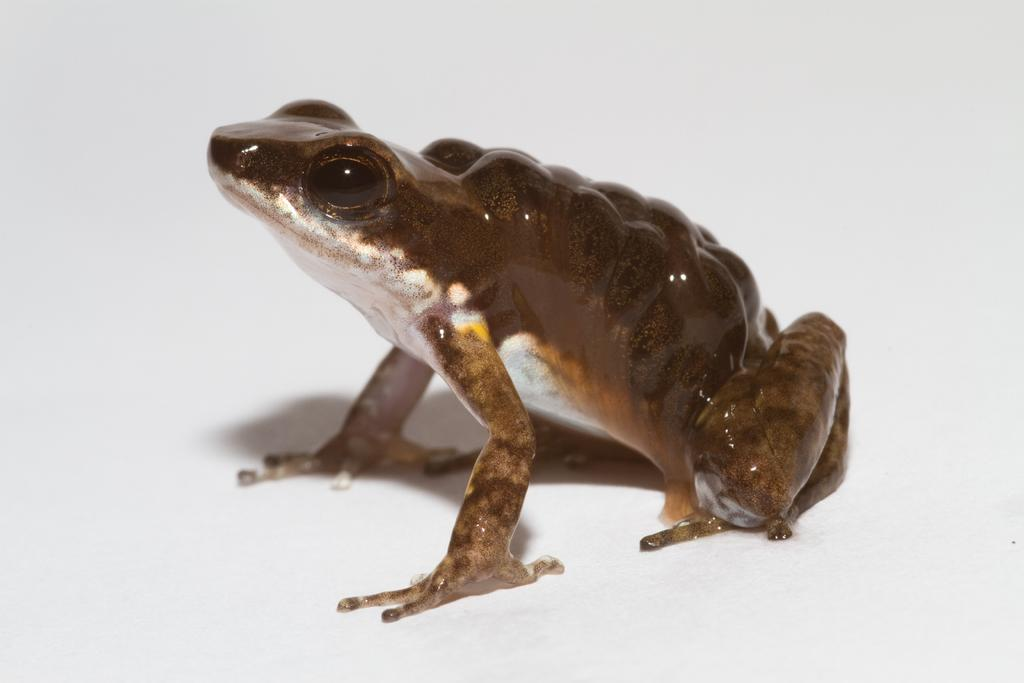What is the main subject in the center of the image? There is a frog in the center of the image. What type of flavor can be tasted in the image? There is no flavor present in the image, as it features a frog and not any food or drink. 